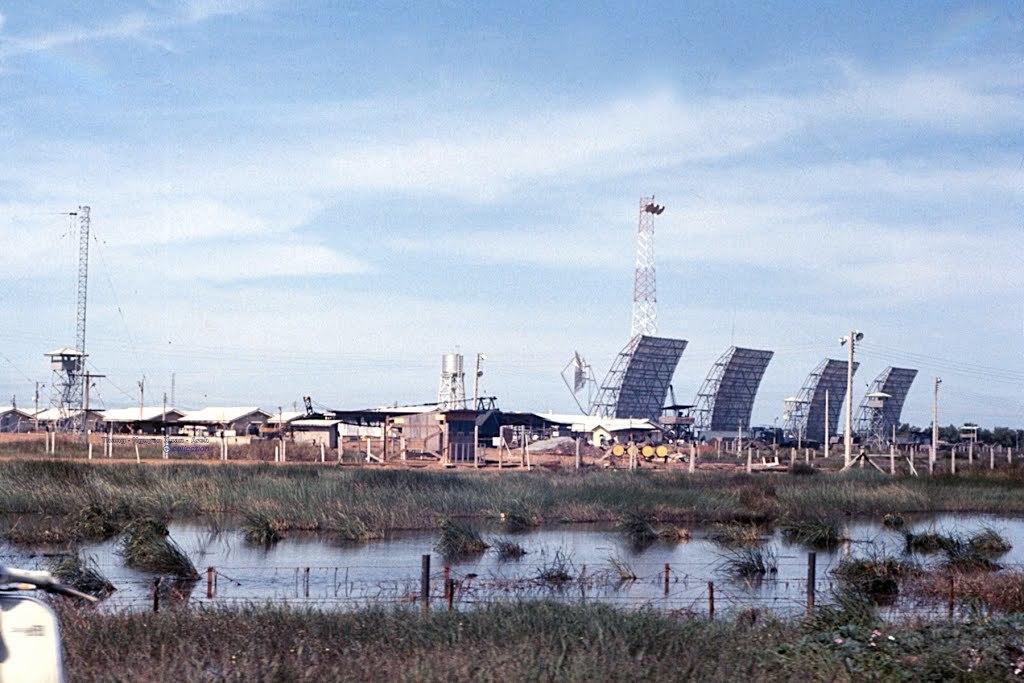In one or two sentences, can you explain what this image depicts? In the picture I can see water and there is greenery grass on either sides of it and there are few buildings,towers and some other objects on it. 